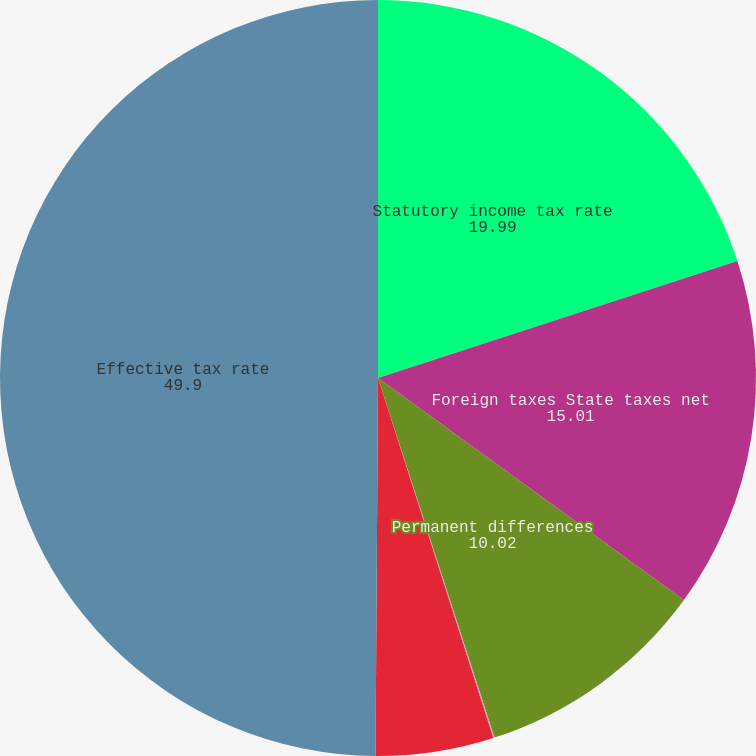Convert chart to OTSL. <chart><loc_0><loc_0><loc_500><loc_500><pie_chart><fcel>Statutory income tax rate<fcel>Foreign taxes State taxes net<fcel>Permanent differences<fcel>Stock based compensation<fcel>Other<fcel>Effective tax rate<nl><fcel>19.99%<fcel>15.01%<fcel>10.02%<fcel>0.05%<fcel>5.04%<fcel>49.9%<nl></chart> 